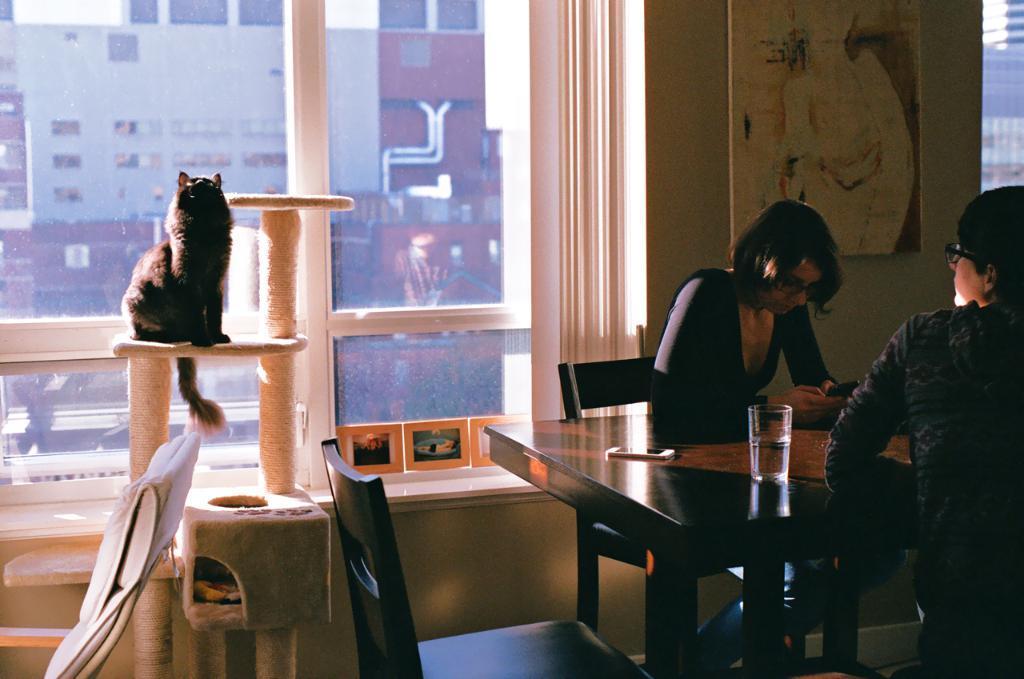Could you give a brief overview of what you see in this image? In this image i can see 2 persons sitting on chairs in front of a table, On the table i can see a glass and a mobile phone. In the background i can see a wall,a photo frame , a cat and a window through which i can see few buildings and the sky. 